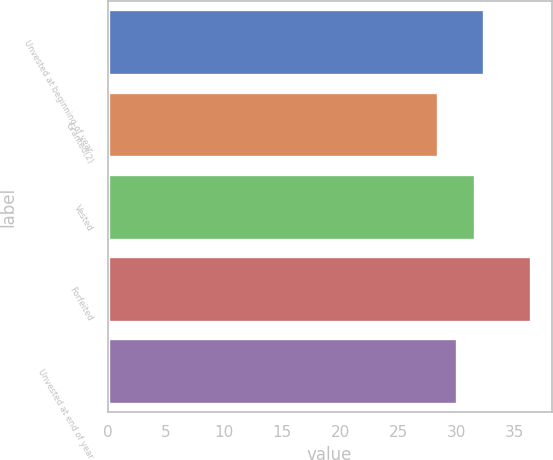Convert chart to OTSL. <chart><loc_0><loc_0><loc_500><loc_500><bar_chart><fcel>Unvested at beginning of year<fcel>Granted(2)<fcel>Vested<fcel>Forfeited<fcel>Unvested at end of year<nl><fcel>32.37<fcel>28.44<fcel>31.58<fcel>36.38<fcel>30.07<nl></chart> 